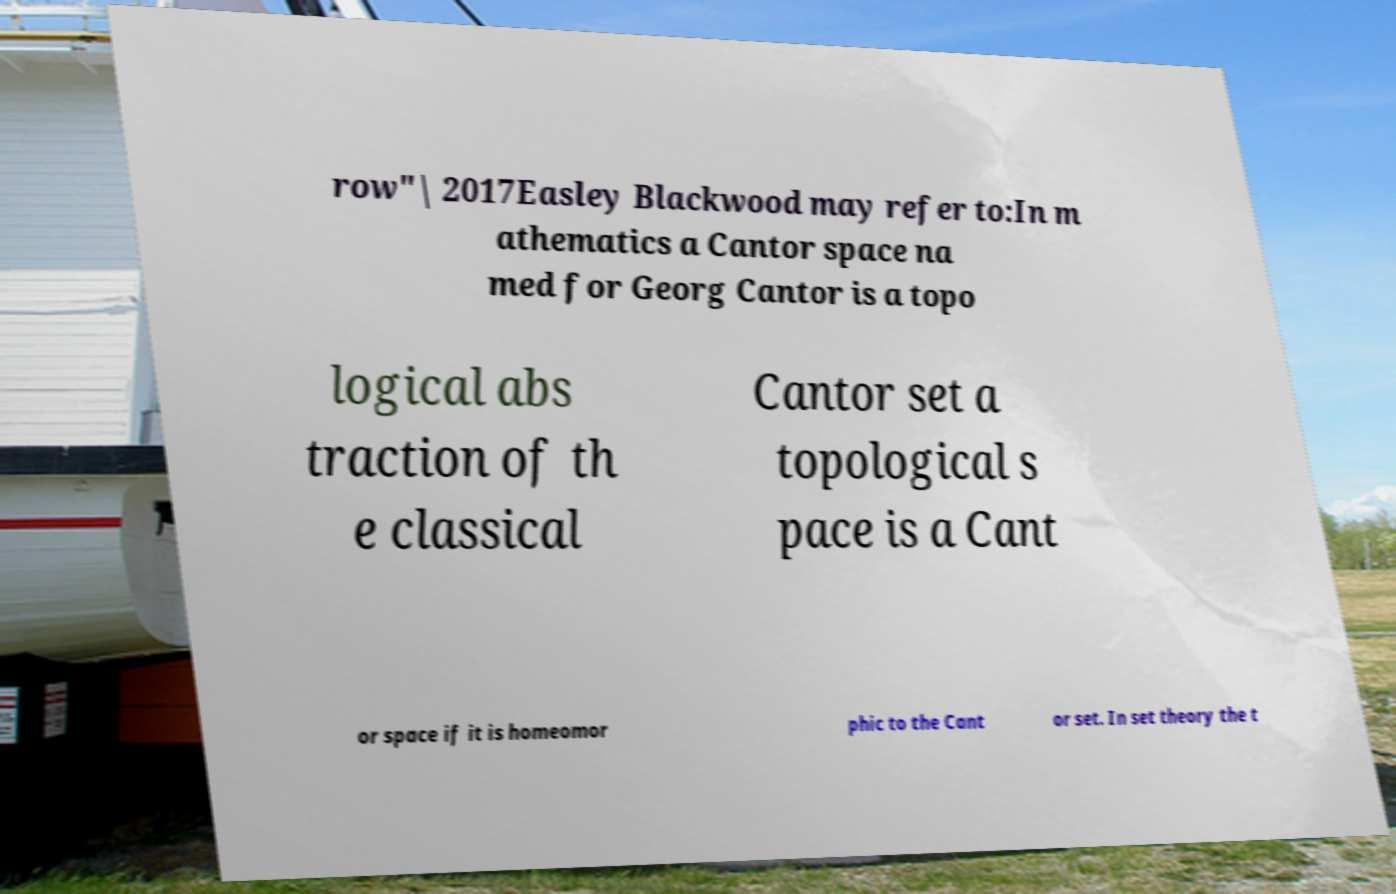Could you extract and type out the text from this image? row"| 2017Easley Blackwood may refer to:In m athematics a Cantor space na med for Georg Cantor is a topo logical abs traction of th e classical Cantor set a topological s pace is a Cant or space if it is homeomor phic to the Cant or set. In set theory the t 